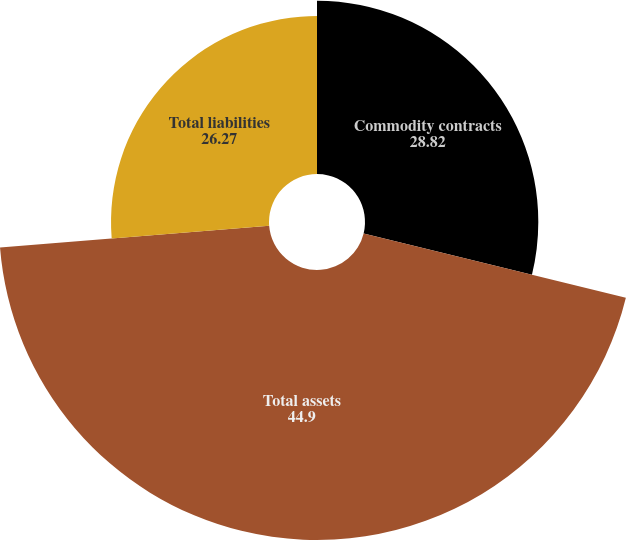<chart> <loc_0><loc_0><loc_500><loc_500><pie_chart><fcel>Commodity contracts<fcel>Total assets<fcel>Total liabilities<nl><fcel>28.82%<fcel>44.9%<fcel>26.27%<nl></chart> 